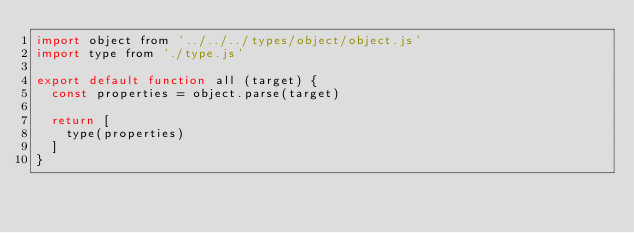Convert code to text. <code><loc_0><loc_0><loc_500><loc_500><_JavaScript_>import object from '../../../types/object/object.js'
import type from './type.js'

export default function all (target) {
  const properties = object.parse(target)

  return [
    type(properties)
  ]
}
</code> 